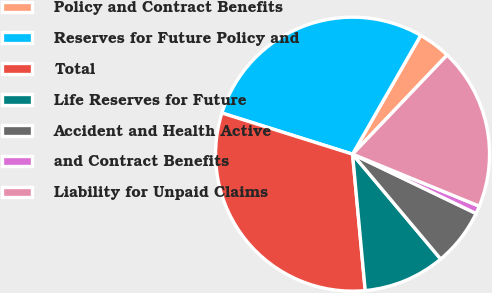Convert chart. <chart><loc_0><loc_0><loc_500><loc_500><pie_chart><fcel>Policy and Contract Benefits<fcel>Reserves for Future Policy and<fcel>Total<fcel>Life Reserves for Future<fcel>Accident and Health Active<fcel>and Contract Benefits<fcel>Liability for Unpaid Claims<nl><fcel>3.84%<fcel>28.43%<fcel>31.33%<fcel>9.65%<fcel>6.75%<fcel>0.93%<fcel>19.07%<nl></chart> 